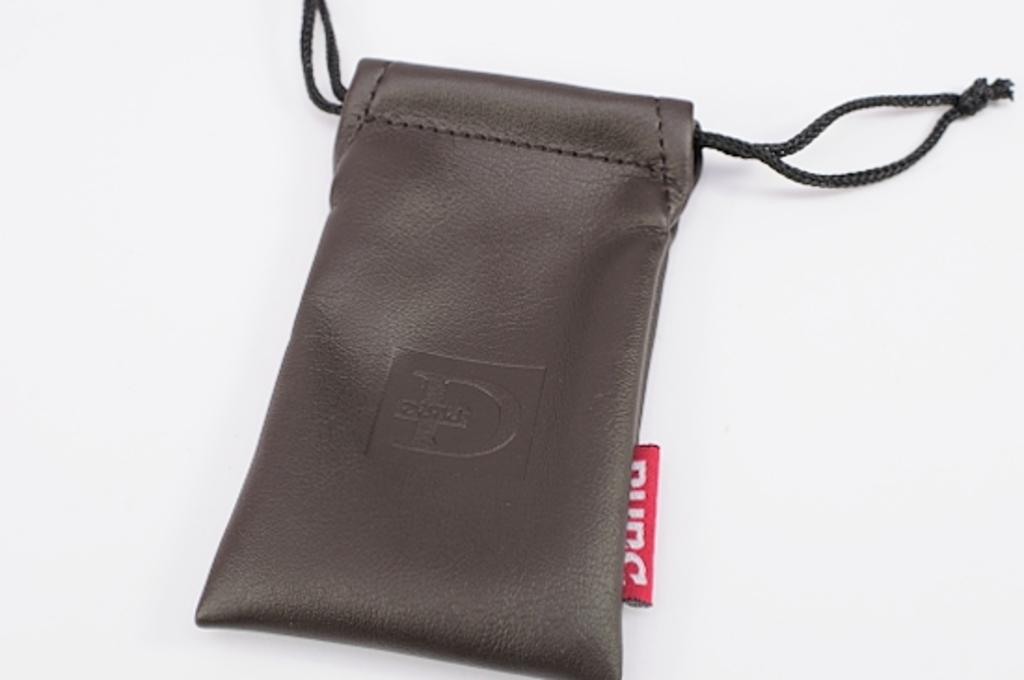What is the main object in the image? There is a pouch in the image. What color are the threads on the pouch? The pouch has black threads. What color is the background of the pouch? The background of the pouch is white. How many vacations does the pouch plan to take this year? The pouch is an inanimate object and does not plan vacations. 